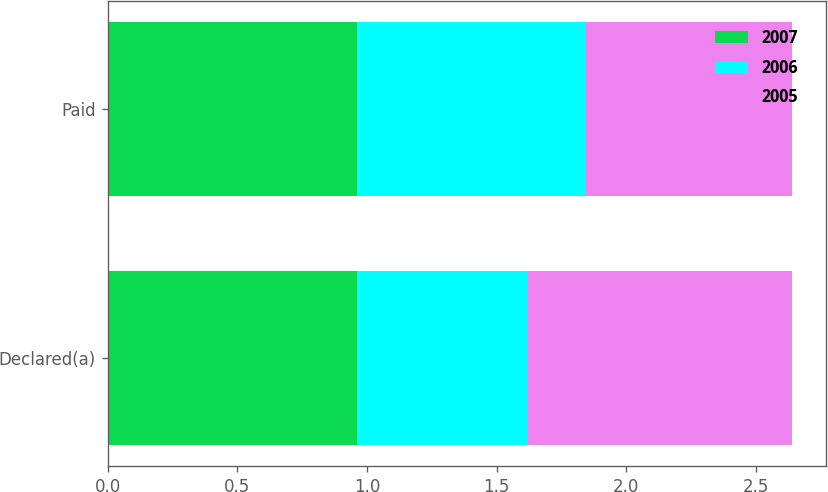Convert chart to OTSL. <chart><loc_0><loc_0><loc_500><loc_500><stacked_bar_chart><ecel><fcel>Declared(a)<fcel>Paid<nl><fcel>2007<fcel>0.96<fcel>0.96<nl><fcel>2006<fcel>0.66<fcel>0.88<nl><fcel>2005<fcel>1.02<fcel>0.8<nl></chart> 